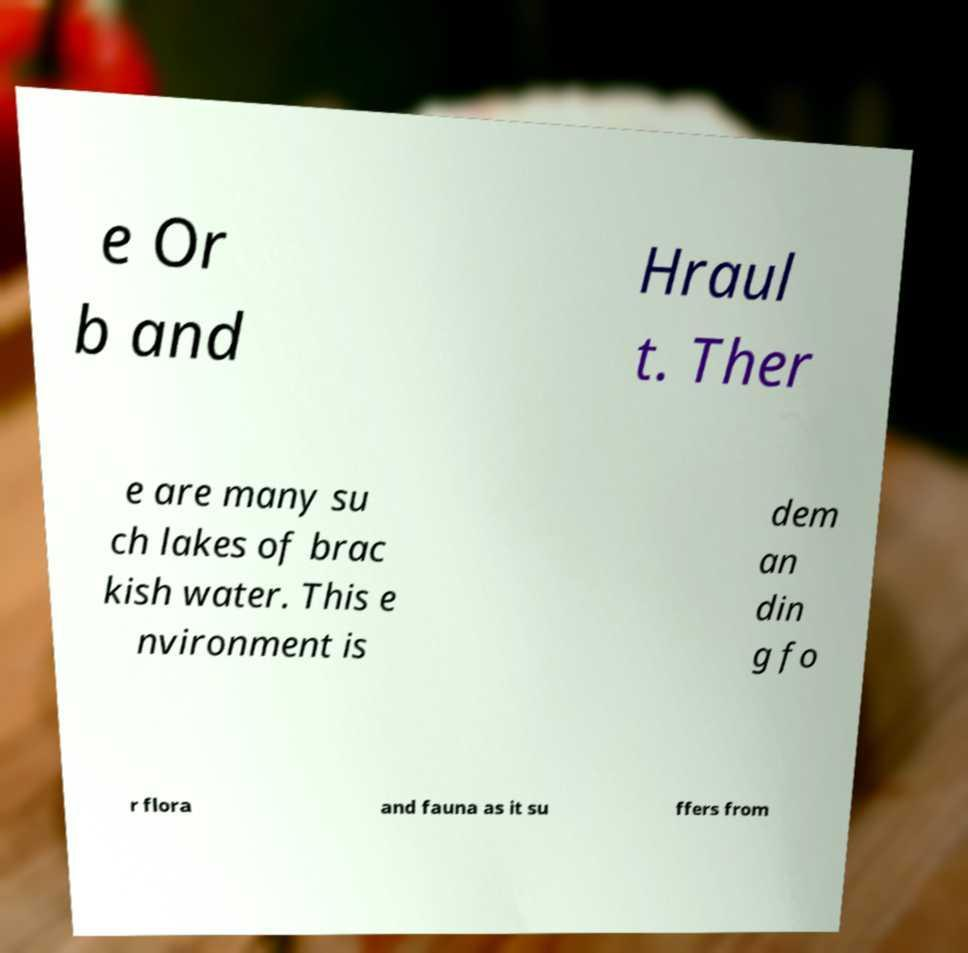Could you assist in decoding the text presented in this image and type it out clearly? e Or b and Hraul t. Ther e are many su ch lakes of brac kish water. This e nvironment is dem an din g fo r flora and fauna as it su ffers from 